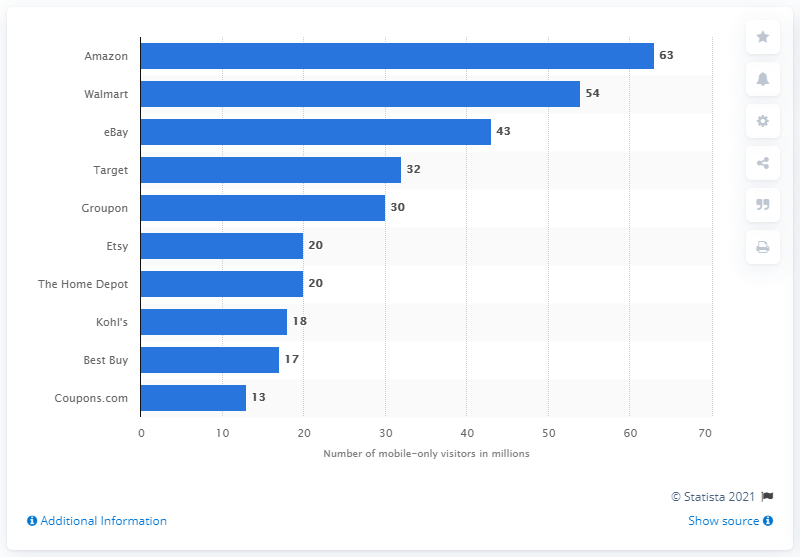Specify some key components in this picture. In September 2018, 63 users exclusively accessed Amazon Sites through their mobile devices. 